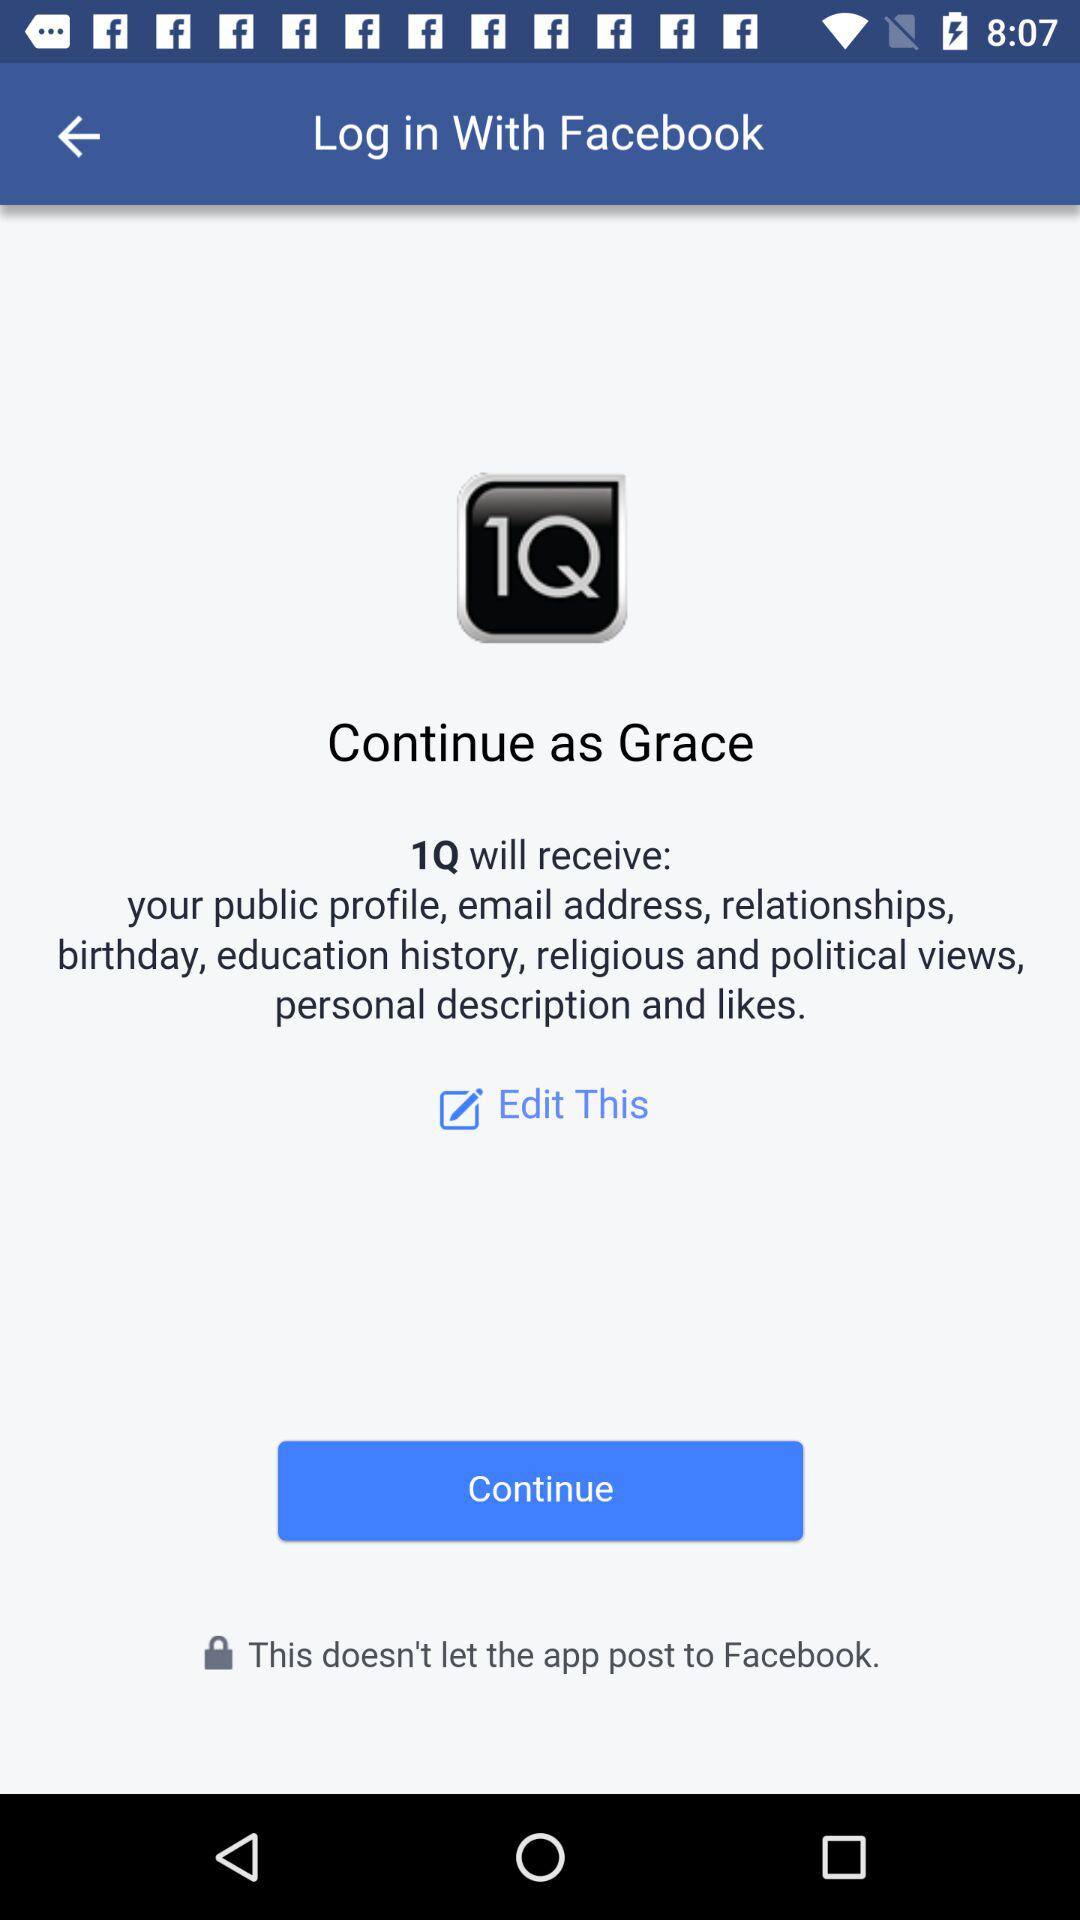What application can be used to login? The application is "Facebook". 